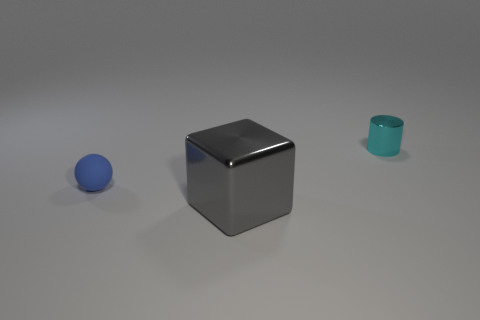Add 2 tiny matte things. How many objects exist? 5 Subtract all cyan cubes. Subtract all purple cylinders. How many cubes are left? 1 Subtract all tiny yellow metallic blocks. Subtract all big gray objects. How many objects are left? 2 Add 1 gray metallic blocks. How many gray metallic blocks are left? 2 Add 2 blue cylinders. How many blue cylinders exist? 2 Subtract 0 green blocks. How many objects are left? 3 Subtract 1 spheres. How many spheres are left? 0 